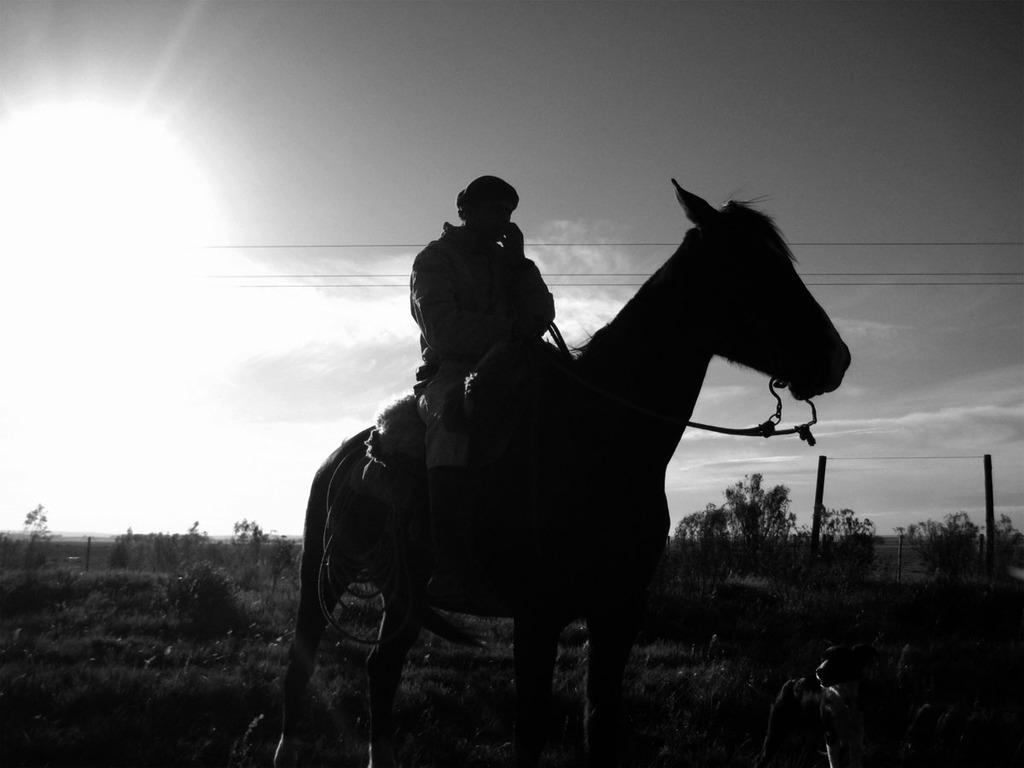Who is the main subject in the image? There is a man in the image. What is the man doing in the image? The man is sitting on a horse. Can you describe the lighting in the image? There is a light on the left side of the image. What can be seen in the background of the image? There are trees in the background of the image. What type of request is the man making to his family in the image? There is no family present in the image, and the man is not making any requests. 